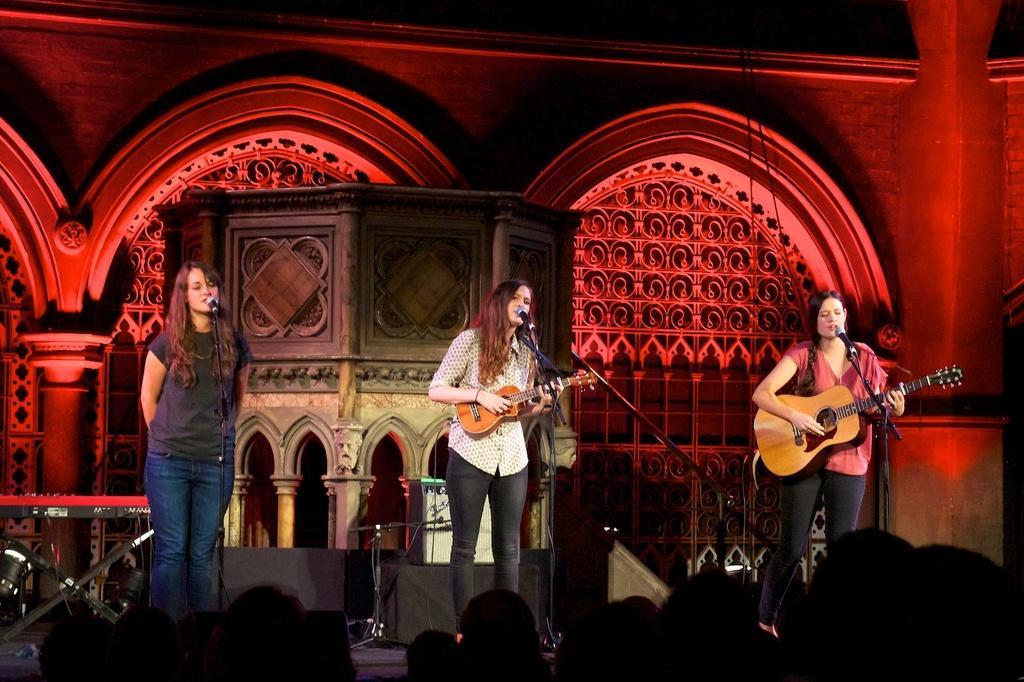Can you describe this image briefly? In this image there are three lady persons two of them are playing guitar and at the left side of the image there is a person standing and singing and at the background of the image there is a red color wall. 